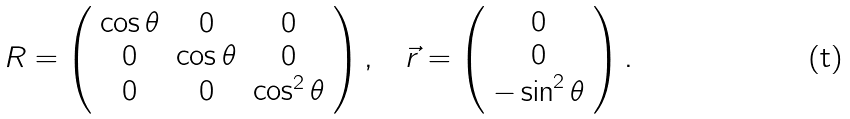Convert formula to latex. <formula><loc_0><loc_0><loc_500><loc_500>R = \left ( \begin{array} { c c c } \cos \theta & 0 & 0 \\ 0 & \cos \theta & 0 \\ 0 & 0 & \cos ^ { 2 } \theta \end{array} \right ) , \quad \vec { r } = \left ( \begin{array} { c } 0 \\ 0 \\ - \sin ^ { 2 } \theta \end{array} \right ) .</formula> 